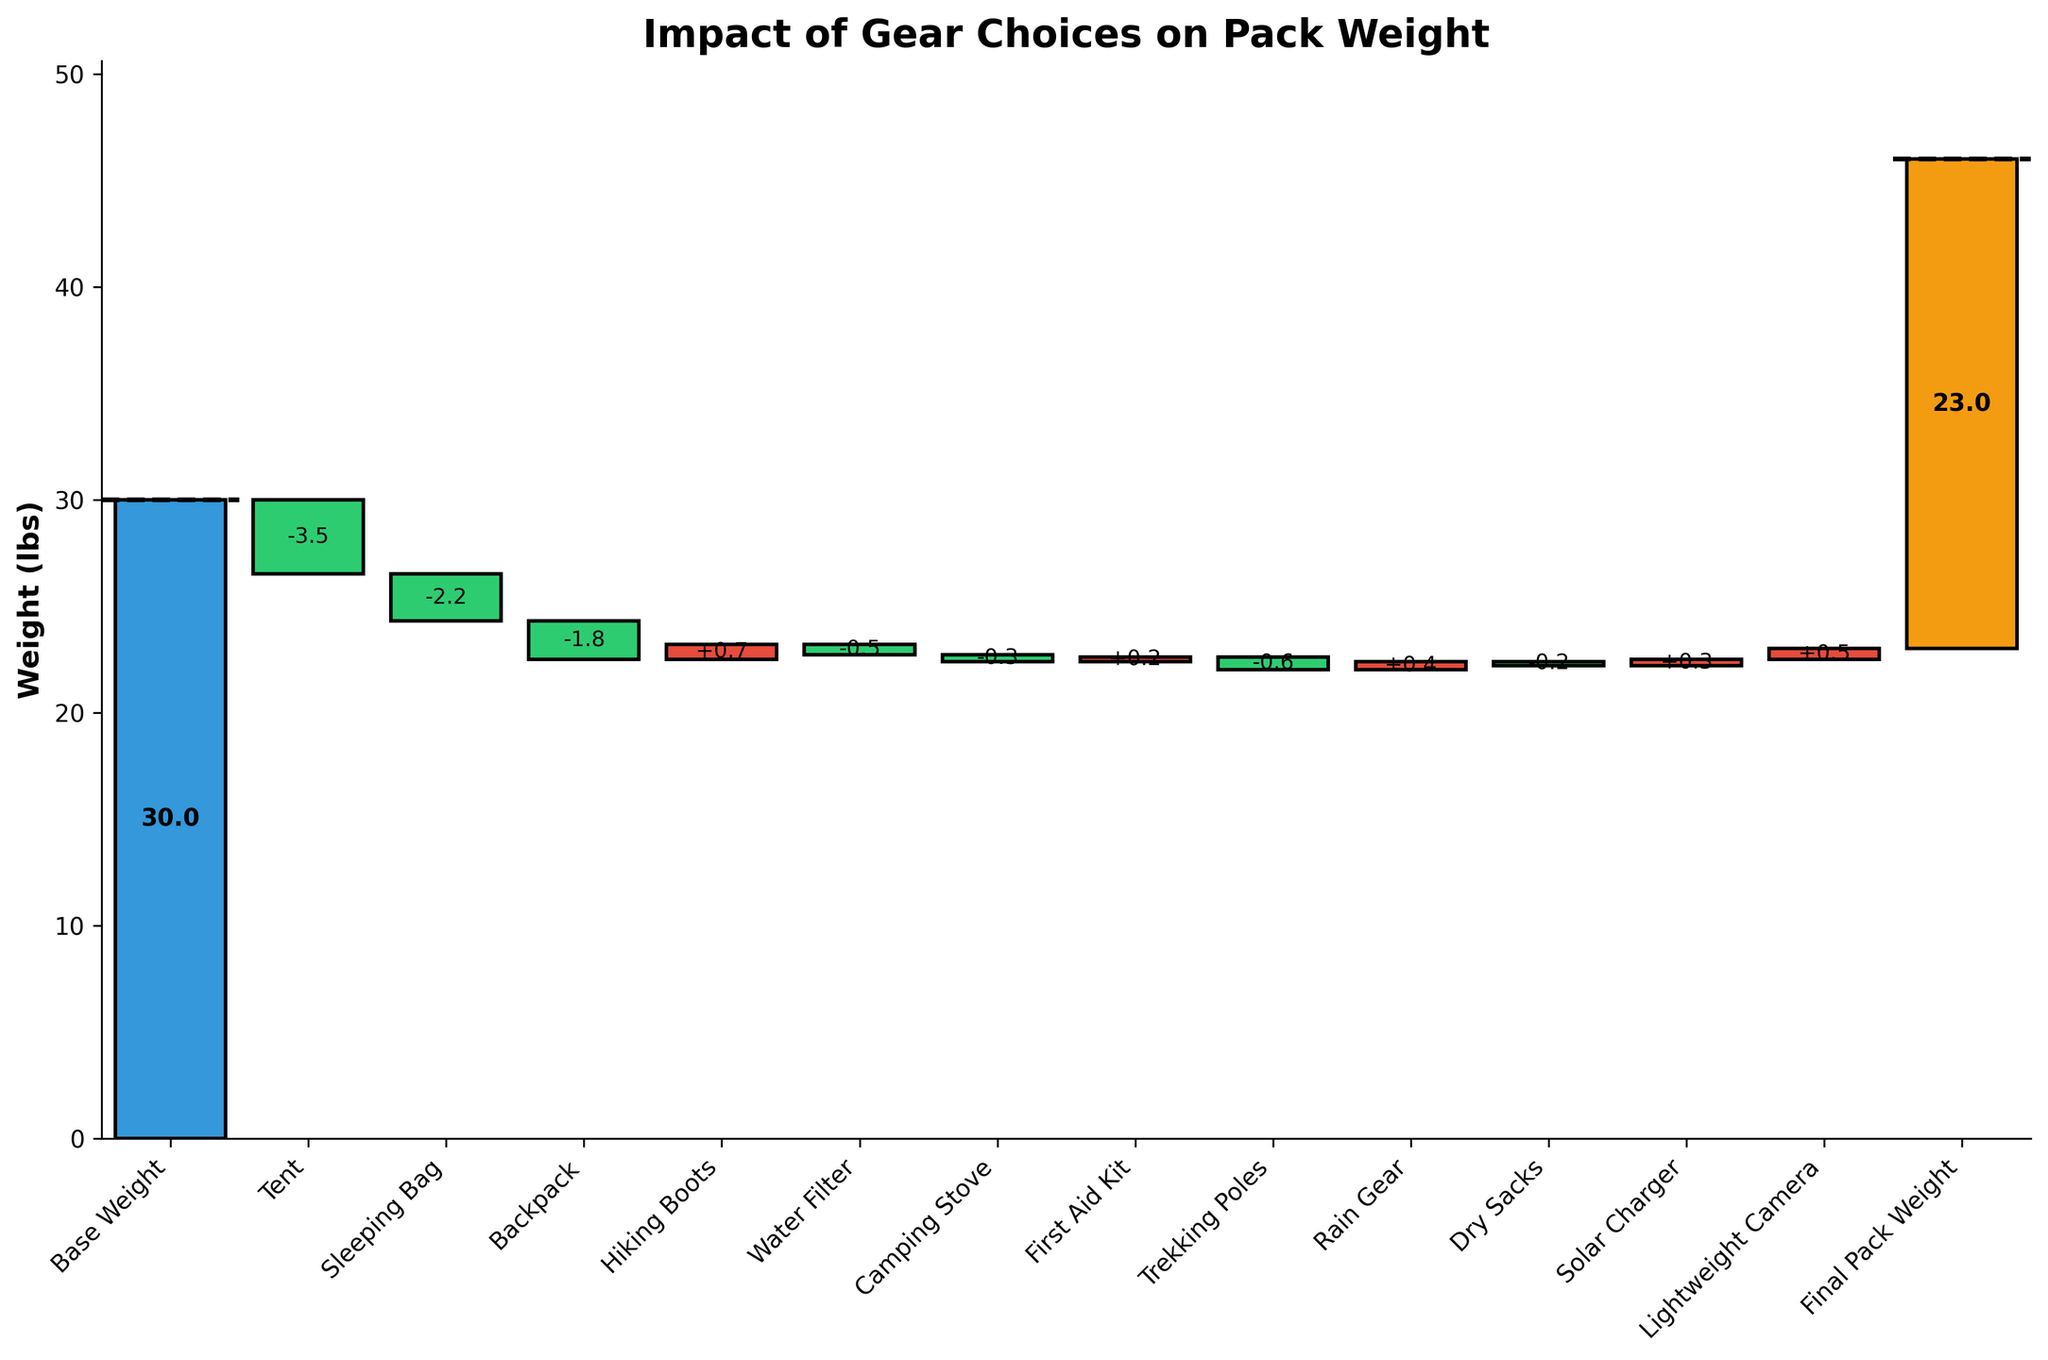How much is the base weight of the pack? The base weight of the pack is the initial weight indicated at the top of the waterfall chart, listed as "Base Weight."
Answer: 30 lbs What is the final weight of the pack? The final pack weight is indicated at the end of the chart labeled "Final Pack Weight."
Answer: 23 lbs Which gear item contributes the most to reducing the pack weight? By looking at the bars in the chart, the item with the largest negative weight change (tallest drop) is the tent.
Answer: Tent Which gear items increase the pack weight? Items that increase the weight are represented by positive values, so by checking the bars that move upwards, these items are Hiking Boots, First Aid Kit, Rain Gear, Solar Charger, and Lightweight Camera.
Answer: Hiking Boots, First Aid Kit, Rain Gear, Solar Charger, Lightweight Camera How much is the weight saved due to the Tent, Sleeping Bag, and Backpack combined? Sum the weight changes for these items: Tent (-3.5), Sleeping Bag (-2.2), and Backpack (-1.8): -3.5 + -2.2 + -1.8 = -7.5 lbs
Answer: -7.5 lbs What is the combined weight contribution of hiking boots and the solar charger? Hiking Boots contribute +0.7 lbs and the Solar Charger contributes +0.3 lbs. Combining these: 0.7 + 0.3 = 1 lbs
Answer: 1 lbs Which item has the least impact on the pack weight? The item with the smallest absolute value weight change is Dry Sacks with -0.2 lbs.
Answer: Dry Sacks What is the net change in weight after accounting for all the gear items? The sum of all weight changes should give the net change: Tent (-3.5) + Sleeping Bag (-2.2) + Backpack (-1.8) + Hiking Boots (+0.7) + Water Filter (-0.5) + Camping Stove (-0.3) + First Aid Kit (+0.2) + Trekking Poles (-0.6) + Rain Gear (+0.4) + Dry Sacks (-0.2) + Solar Charger (+0.3) + Lightweight Camera (+0.5) = -7 lbs
Answer: -7 lbs Are there more items that reduce the pack weight or increase it? Count the number of items with negative and positive weight changes. There are 7 items reducing the weight and 5 items increasing it. More items reduce the weight.
Answer: More items reduce the weight By how much does the Camping Stove reduce the weight of the pack? The weight change due to the Camping Stove is given and indicated on the chart as -0.3 lbs.
Answer: -0.3 lbs 